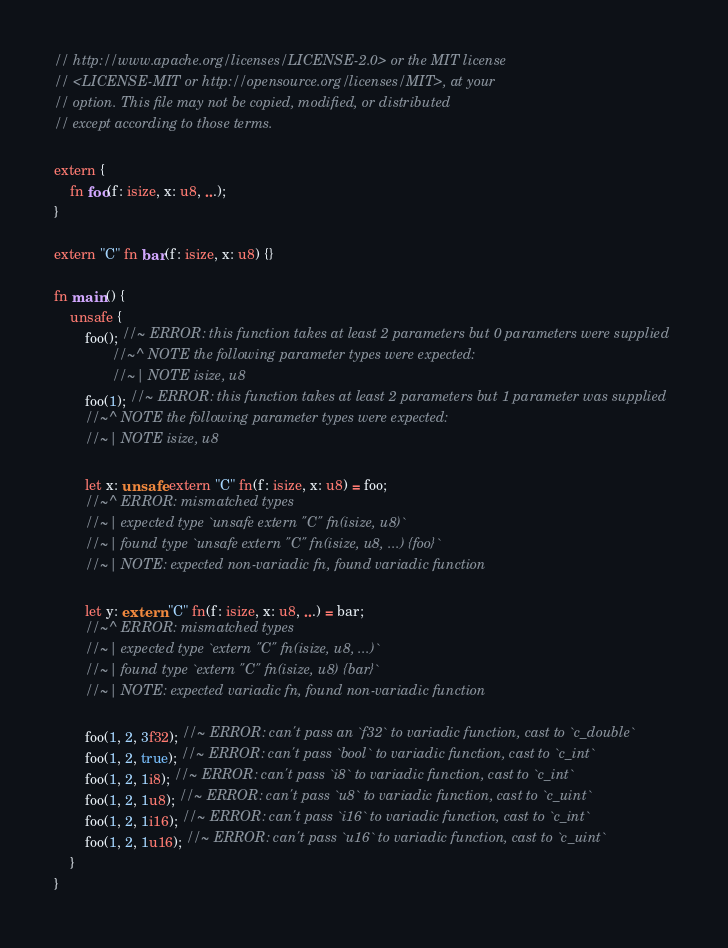Convert code to text. <code><loc_0><loc_0><loc_500><loc_500><_Rust_>// http://www.apache.org/licenses/LICENSE-2.0> or the MIT license
// <LICENSE-MIT or http://opensource.org/licenses/MIT>, at your
// option. This file may not be copied, modified, or distributed
// except according to those terms.

extern {
    fn foo(f: isize, x: u8, ...);
}

extern "C" fn bar(f: isize, x: u8) {}

fn main() {
    unsafe {
        foo(); //~ ERROR: this function takes at least 2 parameters but 0 parameters were supplied
               //~^ NOTE the following parameter types were expected:
               //~| NOTE isize, u8
        foo(1); //~ ERROR: this function takes at least 2 parameters but 1 parameter was supplied
        //~^ NOTE the following parameter types were expected:
        //~| NOTE isize, u8

        let x: unsafe extern "C" fn(f: isize, x: u8) = foo;
        //~^ ERROR: mismatched types
        //~| expected type `unsafe extern "C" fn(isize, u8)`
        //~| found type `unsafe extern "C" fn(isize, u8, ...) {foo}`
        //~| NOTE: expected non-variadic fn, found variadic function

        let y: extern "C" fn(f: isize, x: u8, ...) = bar;
        //~^ ERROR: mismatched types
        //~| expected type `extern "C" fn(isize, u8, ...)`
        //~| found type `extern "C" fn(isize, u8) {bar}`
        //~| NOTE: expected variadic fn, found non-variadic function

        foo(1, 2, 3f32); //~ ERROR: can't pass an `f32` to variadic function, cast to `c_double`
        foo(1, 2, true); //~ ERROR: can't pass `bool` to variadic function, cast to `c_int`
        foo(1, 2, 1i8); //~ ERROR: can't pass `i8` to variadic function, cast to `c_int`
        foo(1, 2, 1u8); //~ ERROR: can't pass `u8` to variadic function, cast to `c_uint`
        foo(1, 2, 1i16); //~ ERROR: can't pass `i16` to variadic function, cast to `c_int`
        foo(1, 2, 1u16); //~ ERROR: can't pass `u16` to variadic function, cast to `c_uint`
    }
}
</code> 